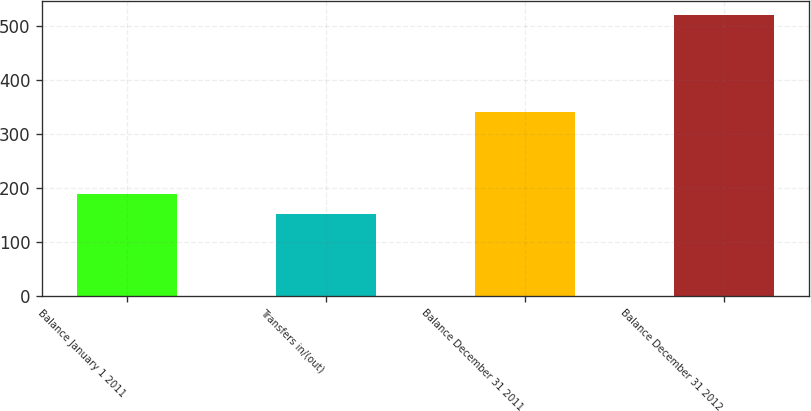Convert chart to OTSL. <chart><loc_0><loc_0><loc_500><loc_500><bar_chart><fcel>Balance January 1 2011<fcel>Transfers in/(out)<fcel>Balance December 31 2011<fcel>Balance December 31 2012<nl><fcel>188.7<fcel>152<fcel>341<fcel>519<nl></chart> 